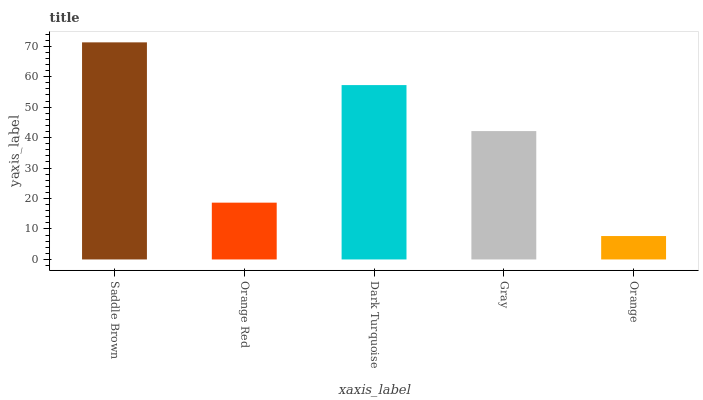Is Orange the minimum?
Answer yes or no. Yes. Is Saddle Brown the maximum?
Answer yes or no. Yes. Is Orange Red the minimum?
Answer yes or no. No. Is Orange Red the maximum?
Answer yes or no. No. Is Saddle Brown greater than Orange Red?
Answer yes or no. Yes. Is Orange Red less than Saddle Brown?
Answer yes or no. Yes. Is Orange Red greater than Saddle Brown?
Answer yes or no. No. Is Saddle Brown less than Orange Red?
Answer yes or no. No. Is Gray the high median?
Answer yes or no. Yes. Is Gray the low median?
Answer yes or no. Yes. Is Orange Red the high median?
Answer yes or no. No. Is Dark Turquoise the low median?
Answer yes or no. No. 